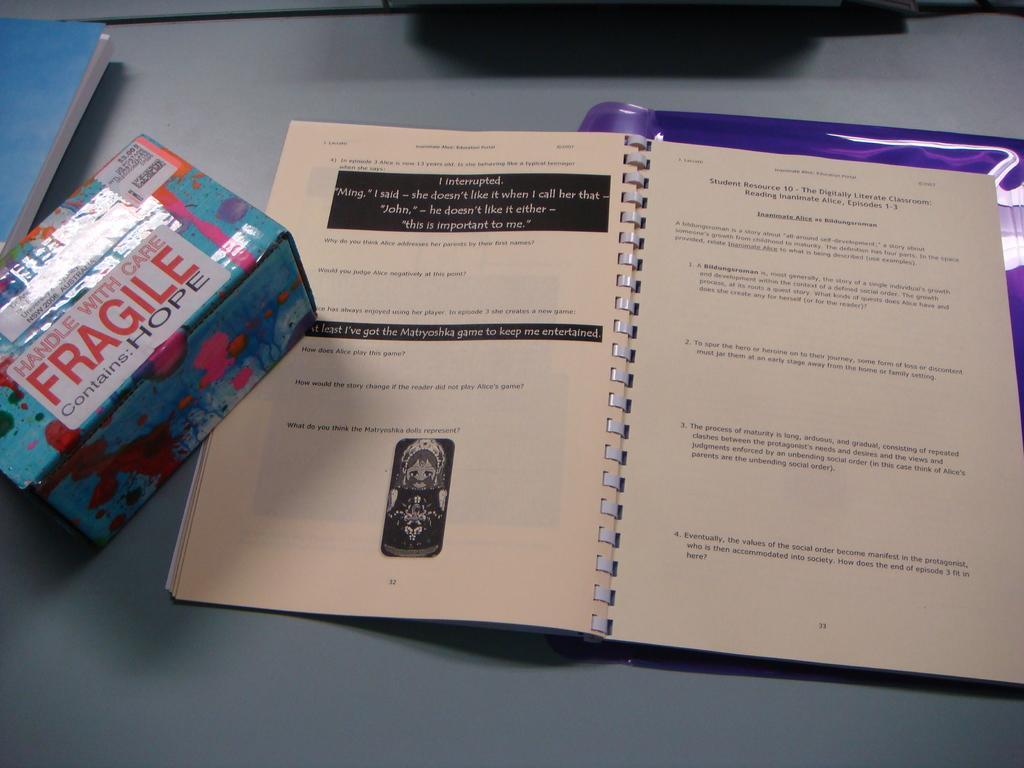How would you summarize this image in a sentence or two? Here in this picture we can see a couple of books and a box present on the table over there. 